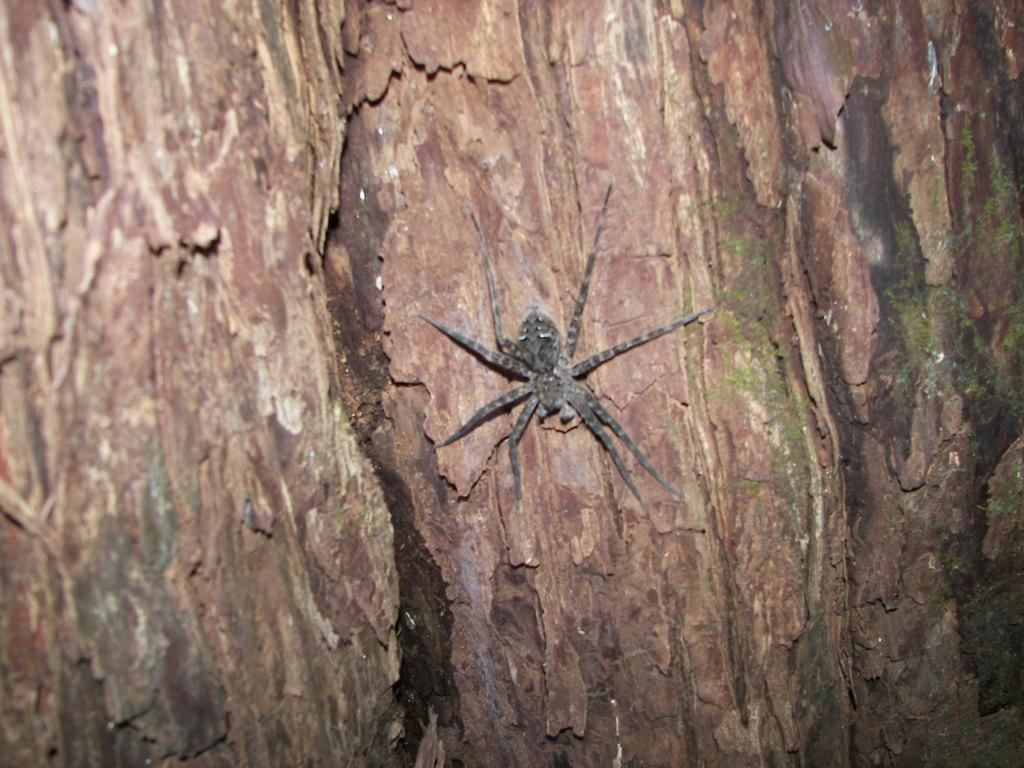What type of animal can be seen in the image? There is a spider in the image. What is the main subject or object in the image? The image appears to depict a tree trunk. Who is sitting on the throne in the image? There is no throne present in the image. How many cows can be seen grazing near the tree trunk in the image? There are no cows present in the image. 